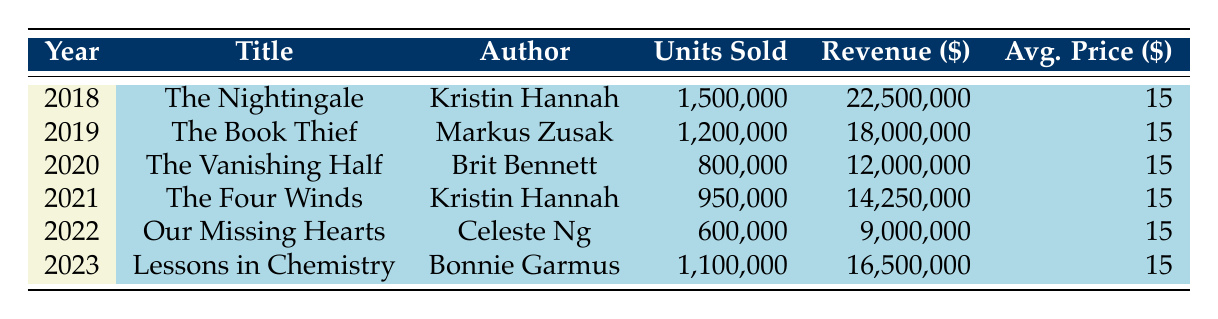What was the title of the book with the highest sales in 2018? Looking at the table, I can see that "The Nightingale" by Kristin Hannah had the highest units sold in 2018, with 1,500,000 copies.
Answer: The Nightingale How many units were sold in 2020? The table indicates that "The Vanishing Half" by Brit Bennett sold 800,000 units in 2020.
Answer: 800,000 What is the total revenue generated by historical fiction books from 2019 to 2021? The revenues for each year are: 2019 - $18,000,000, 2020 - $12,000,000, and 2021 - $14,250,000. Adding these together gives: 18,000,000 + 12,000,000 + 14,250,000 = 44,250,000.
Answer: 44,250,000 Did "Our Missing Hearts" sell more units than "Lessons in Chemistry"? "Our Missing Hearts" sold 600,000 units while "Lessons in Chemistry" sold 1,100,000 units. Since 600,000 is less than 1,100,000, the statement is false.
Answer: No What year experienced the lowest sales in terms of units sold? Reviewing the units sold, 2022 shows the lowest sales with "Our Missing Hearts" at 600,000 units sold, compared to all other years.
Answer: 2022 If we consider the average price of the books, what is the total revenue for all years combined? Each book sold for an average price of $15. The total units sold over the years are: 1,500,000 + 1,200,000 + 800,000 + 950,000 + 600,000 + 1,100,000 = 5,150,000. Multiplying the total units by the average price gives: 5,150,000 * 15 = 77,250,000.
Answer: 77,250,000 Which author had the highest cumulative sales across all years presented in the table? Analyzing the data: Kristin Hannah (1,500,000 + 950,000), Markus Zusak (1,200,000), Brit Bennett (800,000), Celeste Ng (600,000), and Bonnie Garmus (1,100,000) gives: Kristin Hannah = 2,450,000, Markus Zusak = 1,200,000, Brit Bennett = 800,000, Celeste Ng = 600,000, Bonnie Garmus = 1,100,000. Therefore, Kristin Hannah had the highest cumulative sales at 2,450,000.
Answer: Kristin Hannah Was there a year where no books sold the average price of $15? Since all books listed in the table sold for an average price of $15, there were no years where the average price was different than this. Therefore, the statement is false.
Answer: No What is the average number of units sold per year from 2018 to 2023? Summing the units sold gives: 1,500,000 + 1,200,000 + 800,000 + 950,000 + 600,000 + 1,100,000 = 5,150,000 units. There are 6 years, so the average is: 5,150,000 / 6 ≈ 858,333.33.
Answer: 858,333.33 